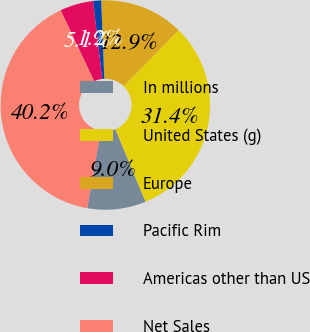Convert chart to OTSL. <chart><loc_0><loc_0><loc_500><loc_500><pie_chart><fcel>In millions<fcel>United States (g)<fcel>Europe<fcel>Pacific Rim<fcel>Americas other than US<fcel>Net Sales<nl><fcel>9.04%<fcel>31.41%<fcel>12.94%<fcel>1.25%<fcel>5.14%<fcel>40.22%<nl></chart> 